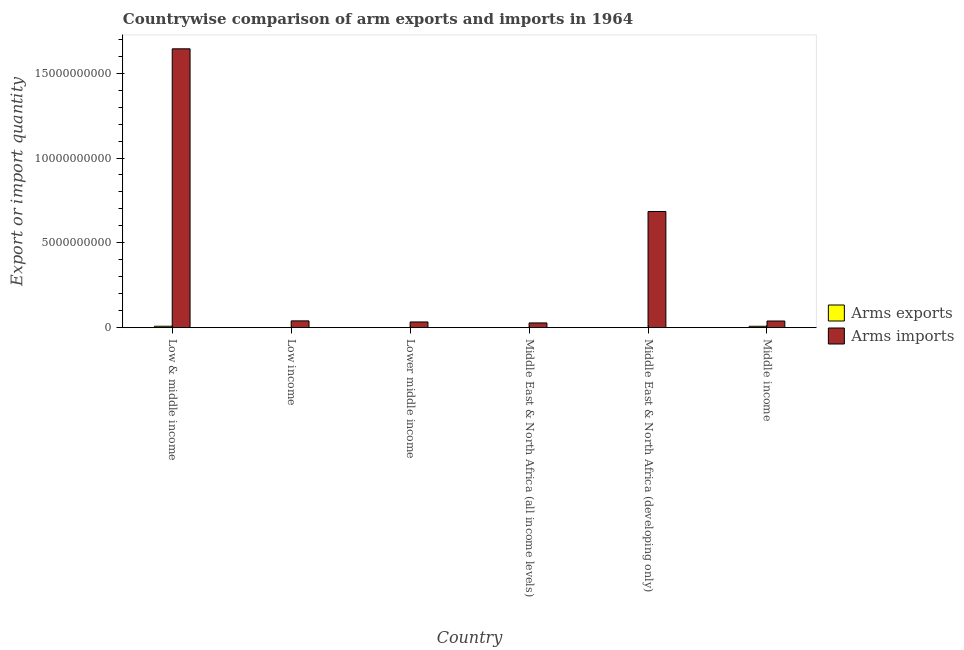How many different coloured bars are there?
Provide a succinct answer. 2. How many groups of bars are there?
Provide a succinct answer. 6. Are the number of bars per tick equal to the number of legend labels?
Provide a succinct answer. Yes. How many bars are there on the 2nd tick from the left?
Ensure brevity in your answer.  2. How many bars are there on the 6th tick from the right?
Your answer should be compact. 2. What is the label of the 3rd group of bars from the left?
Ensure brevity in your answer.  Lower middle income. In how many cases, is the number of bars for a given country not equal to the number of legend labels?
Provide a short and direct response. 0. What is the arms exports in Low income?
Offer a terse response. 3.00e+06. Across all countries, what is the maximum arms exports?
Provide a succinct answer. 8.40e+07. Across all countries, what is the minimum arms exports?
Make the answer very short. 2.00e+06. In which country was the arms imports maximum?
Provide a succinct answer. Low & middle income. In which country was the arms imports minimum?
Keep it short and to the point. Middle East & North Africa (all income levels). What is the total arms exports in the graph?
Offer a very short reply. 1.79e+08. What is the difference between the arms imports in Lower middle income and that in Middle East & North Africa (all income levels)?
Provide a short and direct response. 5.70e+07. What is the difference between the arms imports in Middle income and the arms exports in Low & middle income?
Offer a very short reply. 3.08e+08. What is the average arms exports per country?
Make the answer very short. 2.98e+07. What is the difference between the arms imports and arms exports in Low income?
Make the answer very short. 3.97e+08. In how many countries, is the arms exports greater than 2000000000 ?
Offer a terse response. 0. What is the ratio of the arms imports in Middle East & North Africa (all income levels) to that in Middle East & North Africa (developing only)?
Your answer should be very brief. 0.04. Is the difference between the arms imports in Low & middle income and Low income greater than the difference between the arms exports in Low & middle income and Low income?
Offer a very short reply. Yes. What is the difference between the highest and the lowest arms exports?
Make the answer very short. 8.20e+07. Is the sum of the arms exports in Lower middle income and Middle income greater than the maximum arms imports across all countries?
Your answer should be very brief. No. What does the 2nd bar from the left in Middle East & North Africa (developing only) represents?
Offer a very short reply. Arms imports. What does the 2nd bar from the right in Low & middle income represents?
Give a very brief answer. Arms exports. How many bars are there?
Make the answer very short. 12. Are all the bars in the graph horizontal?
Your answer should be very brief. No. How many countries are there in the graph?
Your answer should be compact. 6. What is the difference between two consecutive major ticks on the Y-axis?
Provide a succinct answer. 5.00e+09. Are the values on the major ticks of Y-axis written in scientific E-notation?
Keep it short and to the point. No. Does the graph contain any zero values?
Keep it short and to the point. No. How are the legend labels stacked?
Offer a very short reply. Vertical. What is the title of the graph?
Make the answer very short. Countrywise comparison of arm exports and imports in 1964. What is the label or title of the X-axis?
Provide a short and direct response. Country. What is the label or title of the Y-axis?
Ensure brevity in your answer.  Export or import quantity. What is the Export or import quantity of Arms exports in Low & middle income?
Your answer should be compact. 8.40e+07. What is the Export or import quantity in Arms imports in Low & middle income?
Keep it short and to the point. 1.64e+1. What is the Export or import quantity in Arms imports in Low income?
Your answer should be very brief. 4.00e+08. What is the Export or import quantity of Arms imports in Lower middle income?
Your response must be concise. 3.36e+08. What is the Export or import quantity of Arms exports in Middle East & North Africa (all income levels)?
Your response must be concise. 7.00e+06. What is the Export or import quantity of Arms imports in Middle East & North Africa (all income levels)?
Your answer should be compact. 2.79e+08. What is the Export or import quantity of Arms exports in Middle East & North Africa (developing only)?
Keep it short and to the point. 2.00e+06. What is the Export or import quantity in Arms imports in Middle East & North Africa (developing only)?
Offer a very short reply. 6.85e+09. What is the Export or import quantity in Arms exports in Middle income?
Give a very brief answer. 8.10e+07. What is the Export or import quantity of Arms imports in Middle income?
Make the answer very short. 3.92e+08. Across all countries, what is the maximum Export or import quantity of Arms exports?
Ensure brevity in your answer.  8.40e+07. Across all countries, what is the maximum Export or import quantity in Arms imports?
Offer a very short reply. 1.64e+1. Across all countries, what is the minimum Export or import quantity in Arms imports?
Give a very brief answer. 2.79e+08. What is the total Export or import quantity in Arms exports in the graph?
Give a very brief answer. 1.79e+08. What is the total Export or import quantity of Arms imports in the graph?
Offer a very short reply. 2.47e+1. What is the difference between the Export or import quantity in Arms exports in Low & middle income and that in Low income?
Ensure brevity in your answer.  8.10e+07. What is the difference between the Export or import quantity in Arms imports in Low & middle income and that in Low income?
Provide a succinct answer. 1.60e+1. What is the difference between the Export or import quantity of Arms exports in Low & middle income and that in Lower middle income?
Give a very brief answer. 8.20e+07. What is the difference between the Export or import quantity in Arms imports in Low & middle income and that in Lower middle income?
Your response must be concise. 1.61e+1. What is the difference between the Export or import quantity of Arms exports in Low & middle income and that in Middle East & North Africa (all income levels)?
Ensure brevity in your answer.  7.70e+07. What is the difference between the Export or import quantity in Arms imports in Low & middle income and that in Middle East & North Africa (all income levels)?
Offer a very short reply. 1.62e+1. What is the difference between the Export or import quantity of Arms exports in Low & middle income and that in Middle East & North Africa (developing only)?
Keep it short and to the point. 8.20e+07. What is the difference between the Export or import quantity in Arms imports in Low & middle income and that in Middle East & North Africa (developing only)?
Provide a succinct answer. 9.59e+09. What is the difference between the Export or import quantity in Arms imports in Low & middle income and that in Middle income?
Offer a terse response. 1.60e+1. What is the difference between the Export or import quantity in Arms imports in Low income and that in Lower middle income?
Your answer should be compact. 6.40e+07. What is the difference between the Export or import quantity in Arms imports in Low income and that in Middle East & North Africa (all income levels)?
Your response must be concise. 1.21e+08. What is the difference between the Export or import quantity in Arms exports in Low income and that in Middle East & North Africa (developing only)?
Provide a succinct answer. 1.00e+06. What is the difference between the Export or import quantity of Arms imports in Low income and that in Middle East & North Africa (developing only)?
Your answer should be compact. -6.45e+09. What is the difference between the Export or import quantity of Arms exports in Low income and that in Middle income?
Provide a short and direct response. -7.80e+07. What is the difference between the Export or import quantity of Arms imports in Low income and that in Middle income?
Offer a terse response. 8.00e+06. What is the difference between the Export or import quantity in Arms exports in Lower middle income and that in Middle East & North Africa (all income levels)?
Offer a terse response. -5.00e+06. What is the difference between the Export or import quantity in Arms imports in Lower middle income and that in Middle East & North Africa (all income levels)?
Provide a succinct answer. 5.70e+07. What is the difference between the Export or import quantity in Arms exports in Lower middle income and that in Middle East & North Africa (developing only)?
Your answer should be compact. 0. What is the difference between the Export or import quantity in Arms imports in Lower middle income and that in Middle East & North Africa (developing only)?
Provide a succinct answer. -6.51e+09. What is the difference between the Export or import quantity in Arms exports in Lower middle income and that in Middle income?
Your answer should be very brief. -7.90e+07. What is the difference between the Export or import quantity in Arms imports in Lower middle income and that in Middle income?
Give a very brief answer. -5.60e+07. What is the difference between the Export or import quantity of Arms imports in Middle East & North Africa (all income levels) and that in Middle East & North Africa (developing only)?
Provide a short and direct response. -6.57e+09. What is the difference between the Export or import quantity in Arms exports in Middle East & North Africa (all income levels) and that in Middle income?
Provide a succinct answer. -7.40e+07. What is the difference between the Export or import quantity in Arms imports in Middle East & North Africa (all income levels) and that in Middle income?
Offer a very short reply. -1.13e+08. What is the difference between the Export or import quantity in Arms exports in Middle East & North Africa (developing only) and that in Middle income?
Ensure brevity in your answer.  -7.90e+07. What is the difference between the Export or import quantity of Arms imports in Middle East & North Africa (developing only) and that in Middle income?
Your response must be concise. 6.46e+09. What is the difference between the Export or import quantity in Arms exports in Low & middle income and the Export or import quantity in Arms imports in Low income?
Ensure brevity in your answer.  -3.16e+08. What is the difference between the Export or import quantity of Arms exports in Low & middle income and the Export or import quantity of Arms imports in Lower middle income?
Ensure brevity in your answer.  -2.52e+08. What is the difference between the Export or import quantity in Arms exports in Low & middle income and the Export or import quantity in Arms imports in Middle East & North Africa (all income levels)?
Offer a very short reply. -1.95e+08. What is the difference between the Export or import quantity of Arms exports in Low & middle income and the Export or import quantity of Arms imports in Middle East & North Africa (developing only)?
Your answer should be compact. -6.76e+09. What is the difference between the Export or import quantity in Arms exports in Low & middle income and the Export or import quantity in Arms imports in Middle income?
Your response must be concise. -3.08e+08. What is the difference between the Export or import quantity of Arms exports in Low income and the Export or import quantity of Arms imports in Lower middle income?
Provide a succinct answer. -3.33e+08. What is the difference between the Export or import quantity of Arms exports in Low income and the Export or import quantity of Arms imports in Middle East & North Africa (all income levels)?
Offer a very short reply. -2.76e+08. What is the difference between the Export or import quantity of Arms exports in Low income and the Export or import quantity of Arms imports in Middle East & North Africa (developing only)?
Keep it short and to the point. -6.84e+09. What is the difference between the Export or import quantity of Arms exports in Low income and the Export or import quantity of Arms imports in Middle income?
Make the answer very short. -3.89e+08. What is the difference between the Export or import quantity of Arms exports in Lower middle income and the Export or import quantity of Arms imports in Middle East & North Africa (all income levels)?
Provide a short and direct response. -2.77e+08. What is the difference between the Export or import quantity of Arms exports in Lower middle income and the Export or import quantity of Arms imports in Middle East & North Africa (developing only)?
Your response must be concise. -6.85e+09. What is the difference between the Export or import quantity in Arms exports in Lower middle income and the Export or import quantity in Arms imports in Middle income?
Your response must be concise. -3.90e+08. What is the difference between the Export or import quantity of Arms exports in Middle East & North Africa (all income levels) and the Export or import quantity of Arms imports in Middle East & North Africa (developing only)?
Your answer should be compact. -6.84e+09. What is the difference between the Export or import quantity of Arms exports in Middle East & North Africa (all income levels) and the Export or import quantity of Arms imports in Middle income?
Provide a succinct answer. -3.85e+08. What is the difference between the Export or import quantity of Arms exports in Middle East & North Africa (developing only) and the Export or import quantity of Arms imports in Middle income?
Make the answer very short. -3.90e+08. What is the average Export or import quantity in Arms exports per country?
Your answer should be compact. 2.98e+07. What is the average Export or import quantity of Arms imports per country?
Offer a terse response. 4.12e+09. What is the difference between the Export or import quantity in Arms exports and Export or import quantity in Arms imports in Low & middle income?
Provide a succinct answer. -1.64e+1. What is the difference between the Export or import quantity of Arms exports and Export or import quantity of Arms imports in Low income?
Give a very brief answer. -3.97e+08. What is the difference between the Export or import quantity in Arms exports and Export or import quantity in Arms imports in Lower middle income?
Keep it short and to the point. -3.34e+08. What is the difference between the Export or import quantity in Arms exports and Export or import quantity in Arms imports in Middle East & North Africa (all income levels)?
Offer a very short reply. -2.72e+08. What is the difference between the Export or import quantity in Arms exports and Export or import quantity in Arms imports in Middle East & North Africa (developing only)?
Ensure brevity in your answer.  -6.85e+09. What is the difference between the Export or import quantity of Arms exports and Export or import quantity of Arms imports in Middle income?
Ensure brevity in your answer.  -3.11e+08. What is the ratio of the Export or import quantity in Arms imports in Low & middle income to that in Low income?
Make the answer very short. 41.09. What is the ratio of the Export or import quantity in Arms exports in Low & middle income to that in Lower middle income?
Make the answer very short. 42. What is the ratio of the Export or import quantity in Arms imports in Low & middle income to that in Lower middle income?
Offer a terse response. 48.92. What is the ratio of the Export or import quantity of Arms exports in Low & middle income to that in Middle East & North Africa (all income levels)?
Ensure brevity in your answer.  12. What is the ratio of the Export or import quantity of Arms imports in Low & middle income to that in Middle East & North Africa (all income levels)?
Your answer should be compact. 58.91. What is the ratio of the Export or import quantity in Arms imports in Low & middle income to that in Middle East & North Africa (developing only)?
Provide a succinct answer. 2.4. What is the ratio of the Export or import quantity of Arms imports in Low & middle income to that in Middle income?
Keep it short and to the point. 41.93. What is the ratio of the Export or import quantity of Arms imports in Low income to that in Lower middle income?
Give a very brief answer. 1.19. What is the ratio of the Export or import quantity in Arms exports in Low income to that in Middle East & North Africa (all income levels)?
Your response must be concise. 0.43. What is the ratio of the Export or import quantity in Arms imports in Low income to that in Middle East & North Africa (all income levels)?
Provide a succinct answer. 1.43. What is the ratio of the Export or import quantity of Arms exports in Low income to that in Middle East & North Africa (developing only)?
Ensure brevity in your answer.  1.5. What is the ratio of the Export or import quantity in Arms imports in Low income to that in Middle East & North Africa (developing only)?
Your response must be concise. 0.06. What is the ratio of the Export or import quantity of Arms exports in Low income to that in Middle income?
Your answer should be compact. 0.04. What is the ratio of the Export or import quantity in Arms imports in Low income to that in Middle income?
Make the answer very short. 1.02. What is the ratio of the Export or import quantity in Arms exports in Lower middle income to that in Middle East & North Africa (all income levels)?
Keep it short and to the point. 0.29. What is the ratio of the Export or import quantity of Arms imports in Lower middle income to that in Middle East & North Africa (all income levels)?
Offer a terse response. 1.2. What is the ratio of the Export or import quantity of Arms exports in Lower middle income to that in Middle East & North Africa (developing only)?
Your answer should be very brief. 1. What is the ratio of the Export or import quantity in Arms imports in Lower middle income to that in Middle East & North Africa (developing only)?
Keep it short and to the point. 0.05. What is the ratio of the Export or import quantity in Arms exports in Lower middle income to that in Middle income?
Offer a very short reply. 0.02. What is the ratio of the Export or import quantity of Arms imports in Lower middle income to that in Middle income?
Keep it short and to the point. 0.86. What is the ratio of the Export or import quantity in Arms exports in Middle East & North Africa (all income levels) to that in Middle East & North Africa (developing only)?
Your answer should be compact. 3.5. What is the ratio of the Export or import quantity in Arms imports in Middle East & North Africa (all income levels) to that in Middle East & North Africa (developing only)?
Make the answer very short. 0.04. What is the ratio of the Export or import quantity in Arms exports in Middle East & North Africa (all income levels) to that in Middle income?
Keep it short and to the point. 0.09. What is the ratio of the Export or import quantity in Arms imports in Middle East & North Africa (all income levels) to that in Middle income?
Your response must be concise. 0.71. What is the ratio of the Export or import quantity of Arms exports in Middle East & North Africa (developing only) to that in Middle income?
Your answer should be very brief. 0.02. What is the ratio of the Export or import quantity in Arms imports in Middle East & North Africa (developing only) to that in Middle income?
Your answer should be very brief. 17.47. What is the difference between the highest and the second highest Export or import quantity of Arms imports?
Make the answer very short. 9.59e+09. What is the difference between the highest and the lowest Export or import quantity of Arms exports?
Give a very brief answer. 8.20e+07. What is the difference between the highest and the lowest Export or import quantity in Arms imports?
Keep it short and to the point. 1.62e+1. 